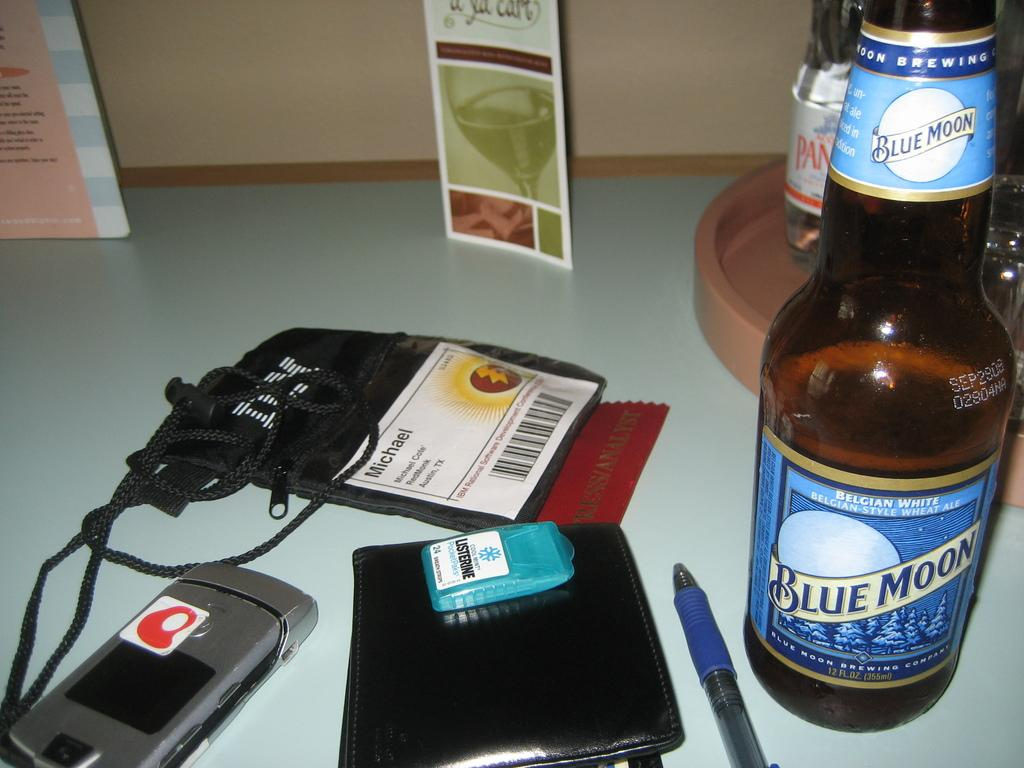<image>
Create a compact narrative representing the image presented. The work pass sitting on the table belongs to a person called Michael. 